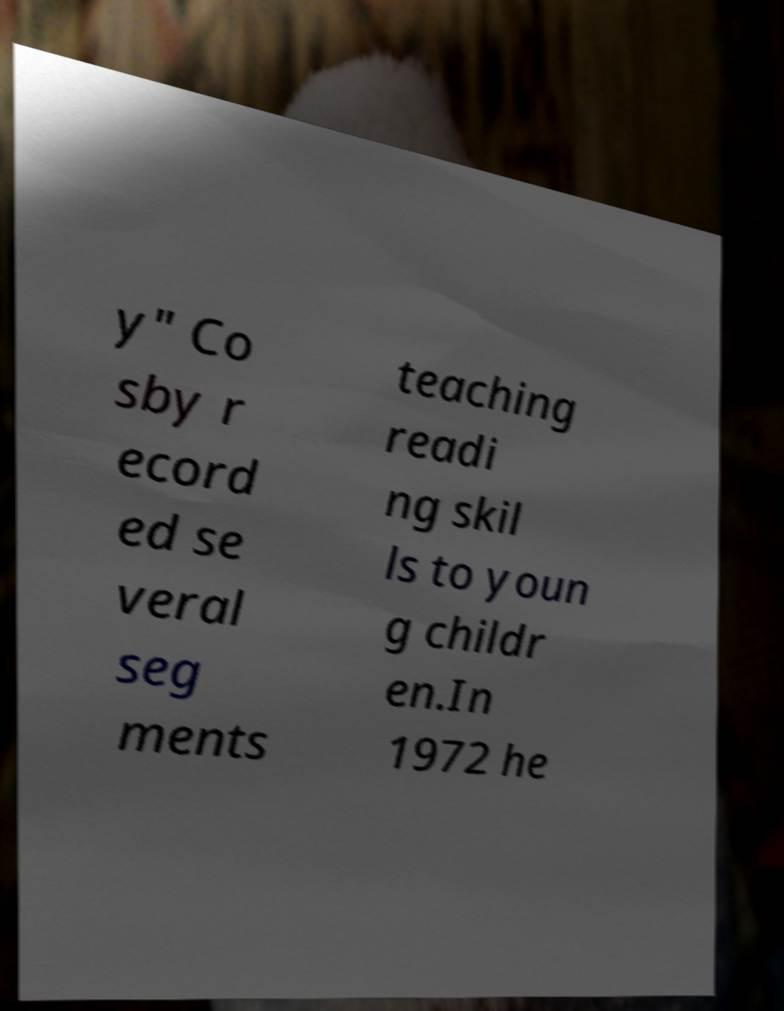Please identify and transcribe the text found in this image. y" Co sby r ecord ed se veral seg ments teaching readi ng skil ls to youn g childr en.In 1972 he 